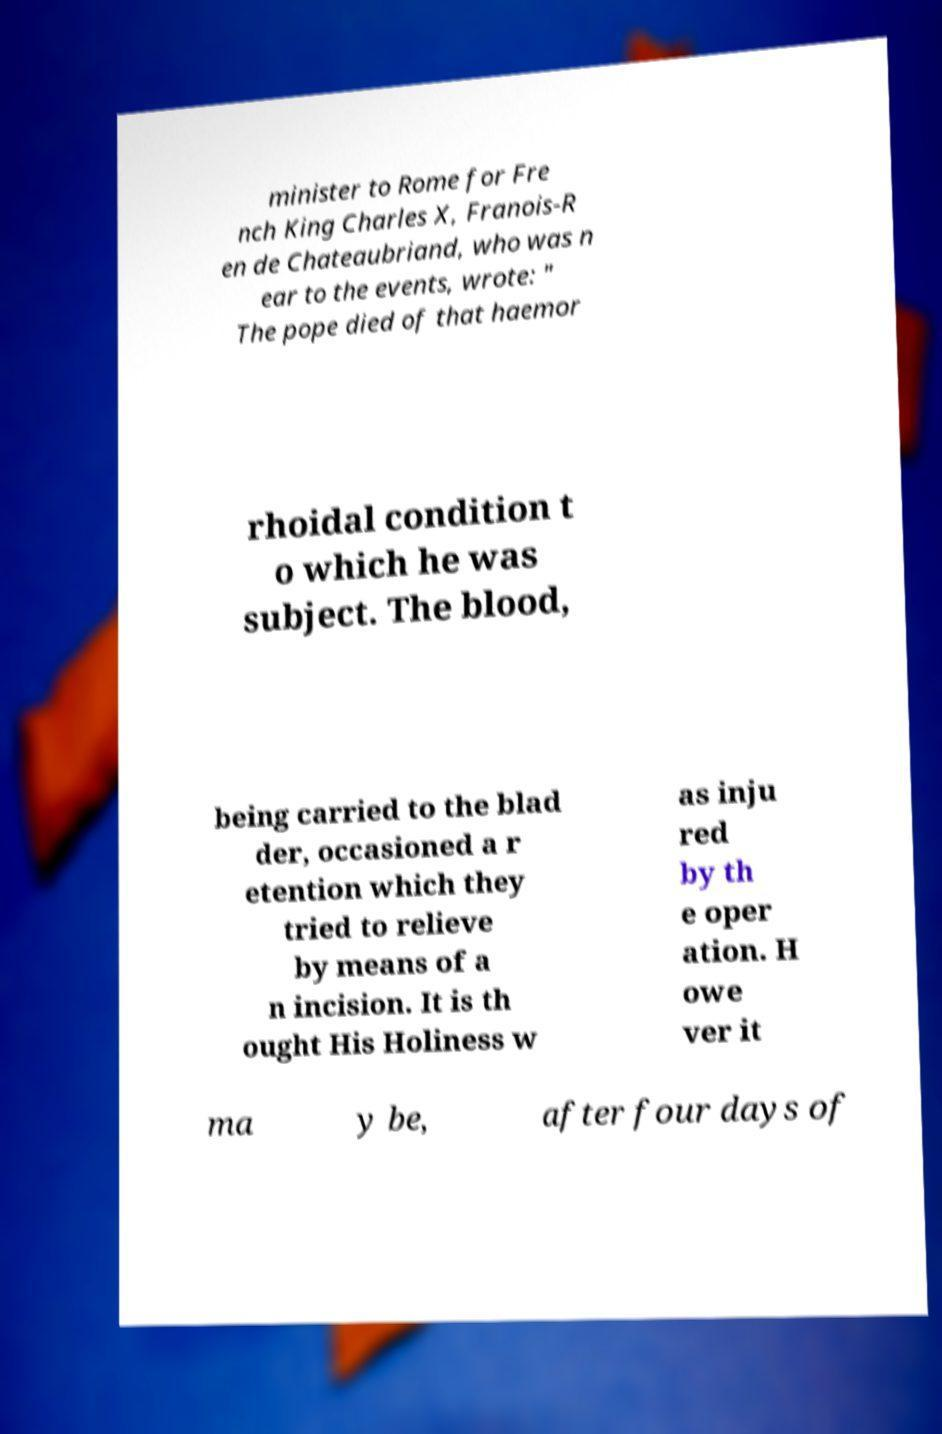Could you extract and type out the text from this image? minister to Rome for Fre nch King Charles X, Franois-R en de Chateaubriand, who was n ear to the events, wrote: " The pope died of that haemor rhoidal condition t o which he was subject. The blood, being carried to the blad der, occasioned a r etention which they tried to relieve by means of a n incision. It is th ought His Holiness w as inju red by th e oper ation. H owe ver it ma y be, after four days of 